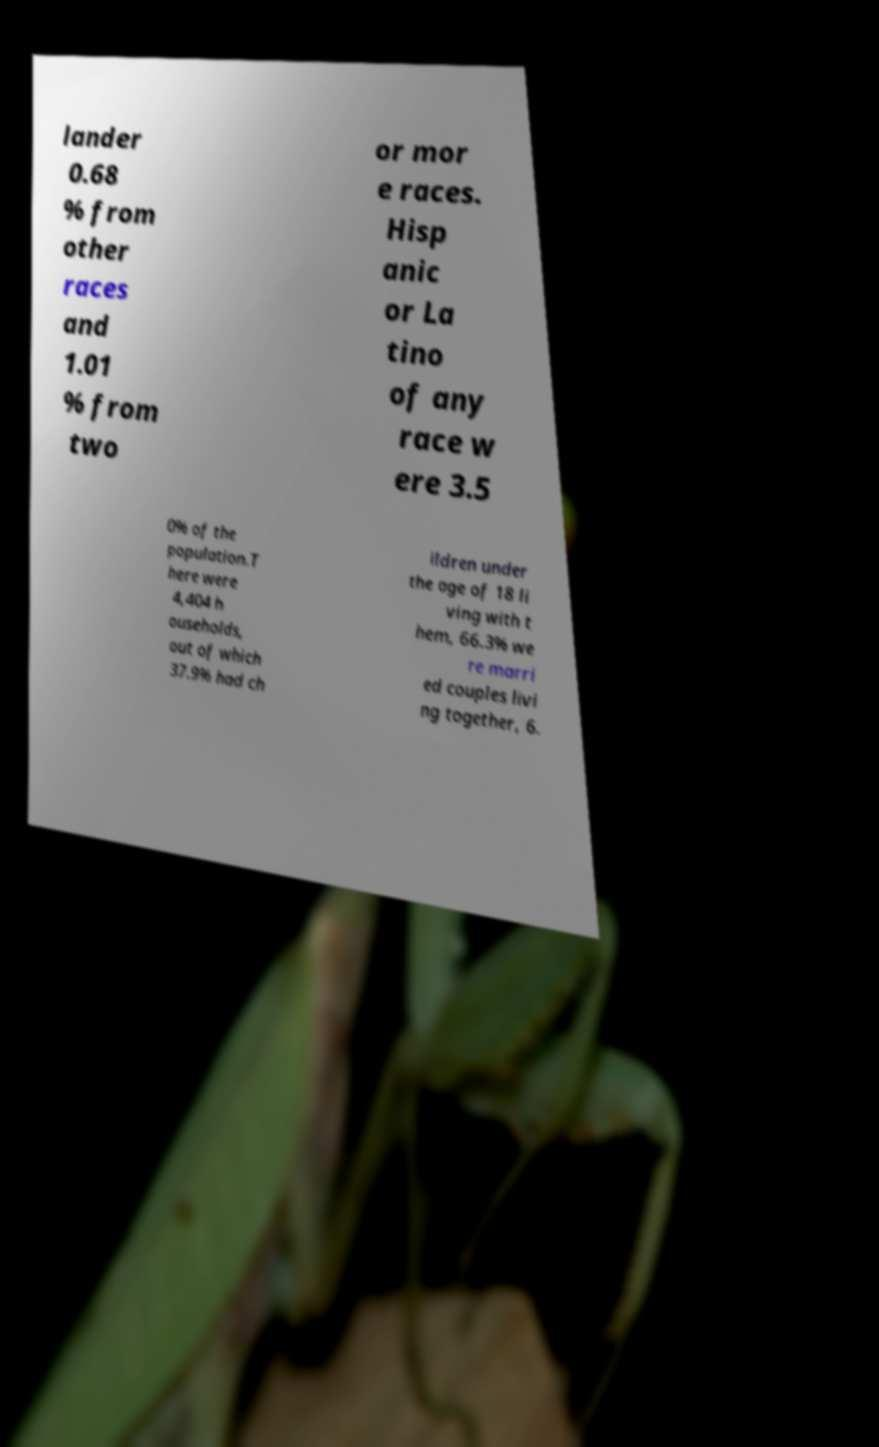I need the written content from this picture converted into text. Can you do that? lander 0.68 % from other races and 1.01 % from two or mor e races. Hisp anic or La tino of any race w ere 3.5 0% of the population.T here were 4,404 h ouseholds, out of which 37.9% had ch ildren under the age of 18 li ving with t hem, 66.3% we re marri ed couples livi ng together, 6. 